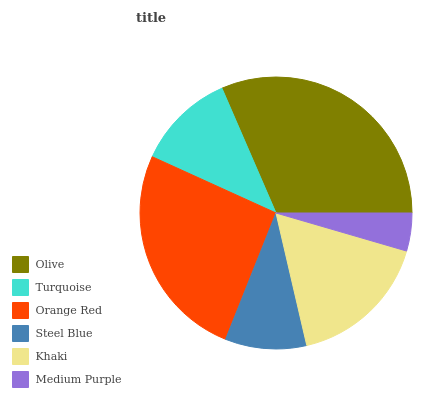Is Medium Purple the minimum?
Answer yes or no. Yes. Is Olive the maximum?
Answer yes or no. Yes. Is Turquoise the minimum?
Answer yes or no. No. Is Turquoise the maximum?
Answer yes or no. No. Is Olive greater than Turquoise?
Answer yes or no. Yes. Is Turquoise less than Olive?
Answer yes or no. Yes. Is Turquoise greater than Olive?
Answer yes or no. No. Is Olive less than Turquoise?
Answer yes or no. No. Is Khaki the high median?
Answer yes or no. Yes. Is Turquoise the low median?
Answer yes or no. Yes. Is Turquoise the high median?
Answer yes or no. No. Is Steel Blue the low median?
Answer yes or no. No. 